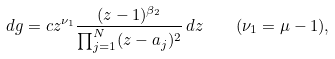Convert formula to latex. <formula><loc_0><loc_0><loc_500><loc_500>d g = c z ^ { \nu _ { 1 } } \frac { ( z - 1 ) ^ { \beta _ { 2 } } } { \prod _ { j = 1 } ^ { N } ( z - a _ { j } ) ^ { 2 } } \, d z \quad ( \nu _ { 1 } = \mu - 1 ) ,</formula> 